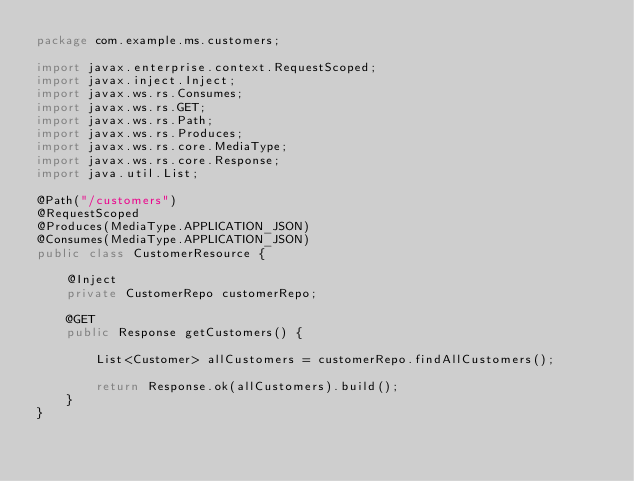Convert code to text. <code><loc_0><loc_0><loc_500><loc_500><_Java_>package com.example.ms.customers;

import javax.enterprise.context.RequestScoped;
import javax.inject.Inject;
import javax.ws.rs.Consumes;
import javax.ws.rs.GET;
import javax.ws.rs.Path;
import javax.ws.rs.Produces;
import javax.ws.rs.core.MediaType;
import javax.ws.rs.core.Response;
import java.util.List;

@Path("/customers")
@RequestScoped
@Produces(MediaType.APPLICATION_JSON)
@Consumes(MediaType.APPLICATION_JSON)
public class CustomerResource {

    @Inject
    private CustomerRepo customerRepo;

    @GET
    public Response getCustomers() {

        List<Customer> allCustomers = customerRepo.findAllCustomers();

        return Response.ok(allCustomers).build();
    }
}
</code> 